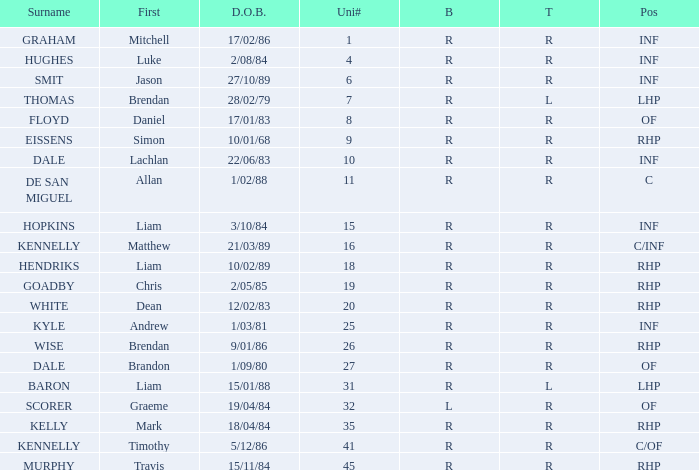Which batter has a uni# of 31? R. 